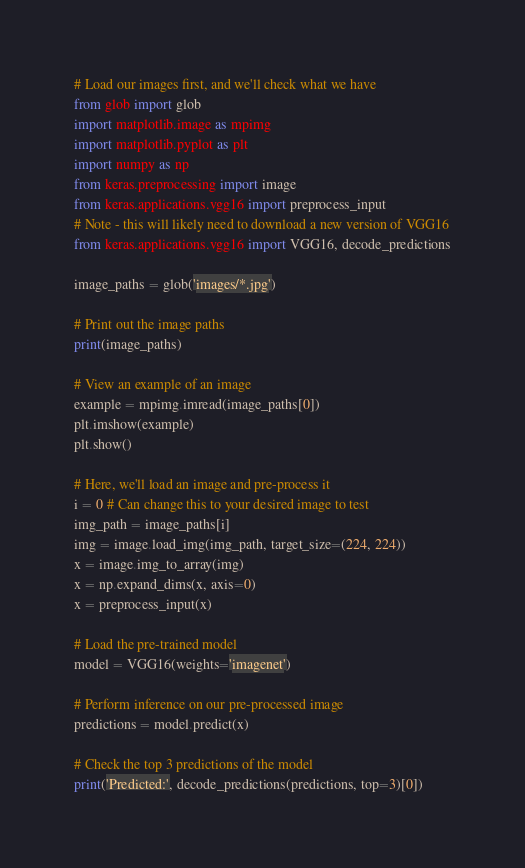Convert code to text. <code><loc_0><loc_0><loc_500><loc_500><_Python_># Load our images first, and we'll check what we have
from glob import glob
import matplotlib.image as mpimg
import matplotlib.pyplot as plt
import numpy as np
from keras.preprocessing import image
from keras.applications.vgg16 import preprocess_input
# Note - this will likely need to download a new version of VGG16
from keras.applications.vgg16 import VGG16, decode_predictions

image_paths = glob('images/*.jpg')

# Print out the image paths
print(image_paths)

# View an example of an image
example = mpimg.imread(image_paths[0])
plt.imshow(example)
plt.show()

# Here, we'll load an image and pre-process it
i = 0 # Can change this to your desired image to test
img_path = image_paths[i]
img = image.load_img(img_path, target_size=(224, 224))
x = image.img_to_array(img)
x = np.expand_dims(x, axis=0)
x = preprocess_input(x)

# Load the pre-trained model
model = VGG16(weights='imagenet')

# Perform inference on our pre-processed image
predictions = model.predict(x)

# Check the top 3 predictions of the model
print('Predicted:', decode_predictions(predictions, top=3)[0])</code> 